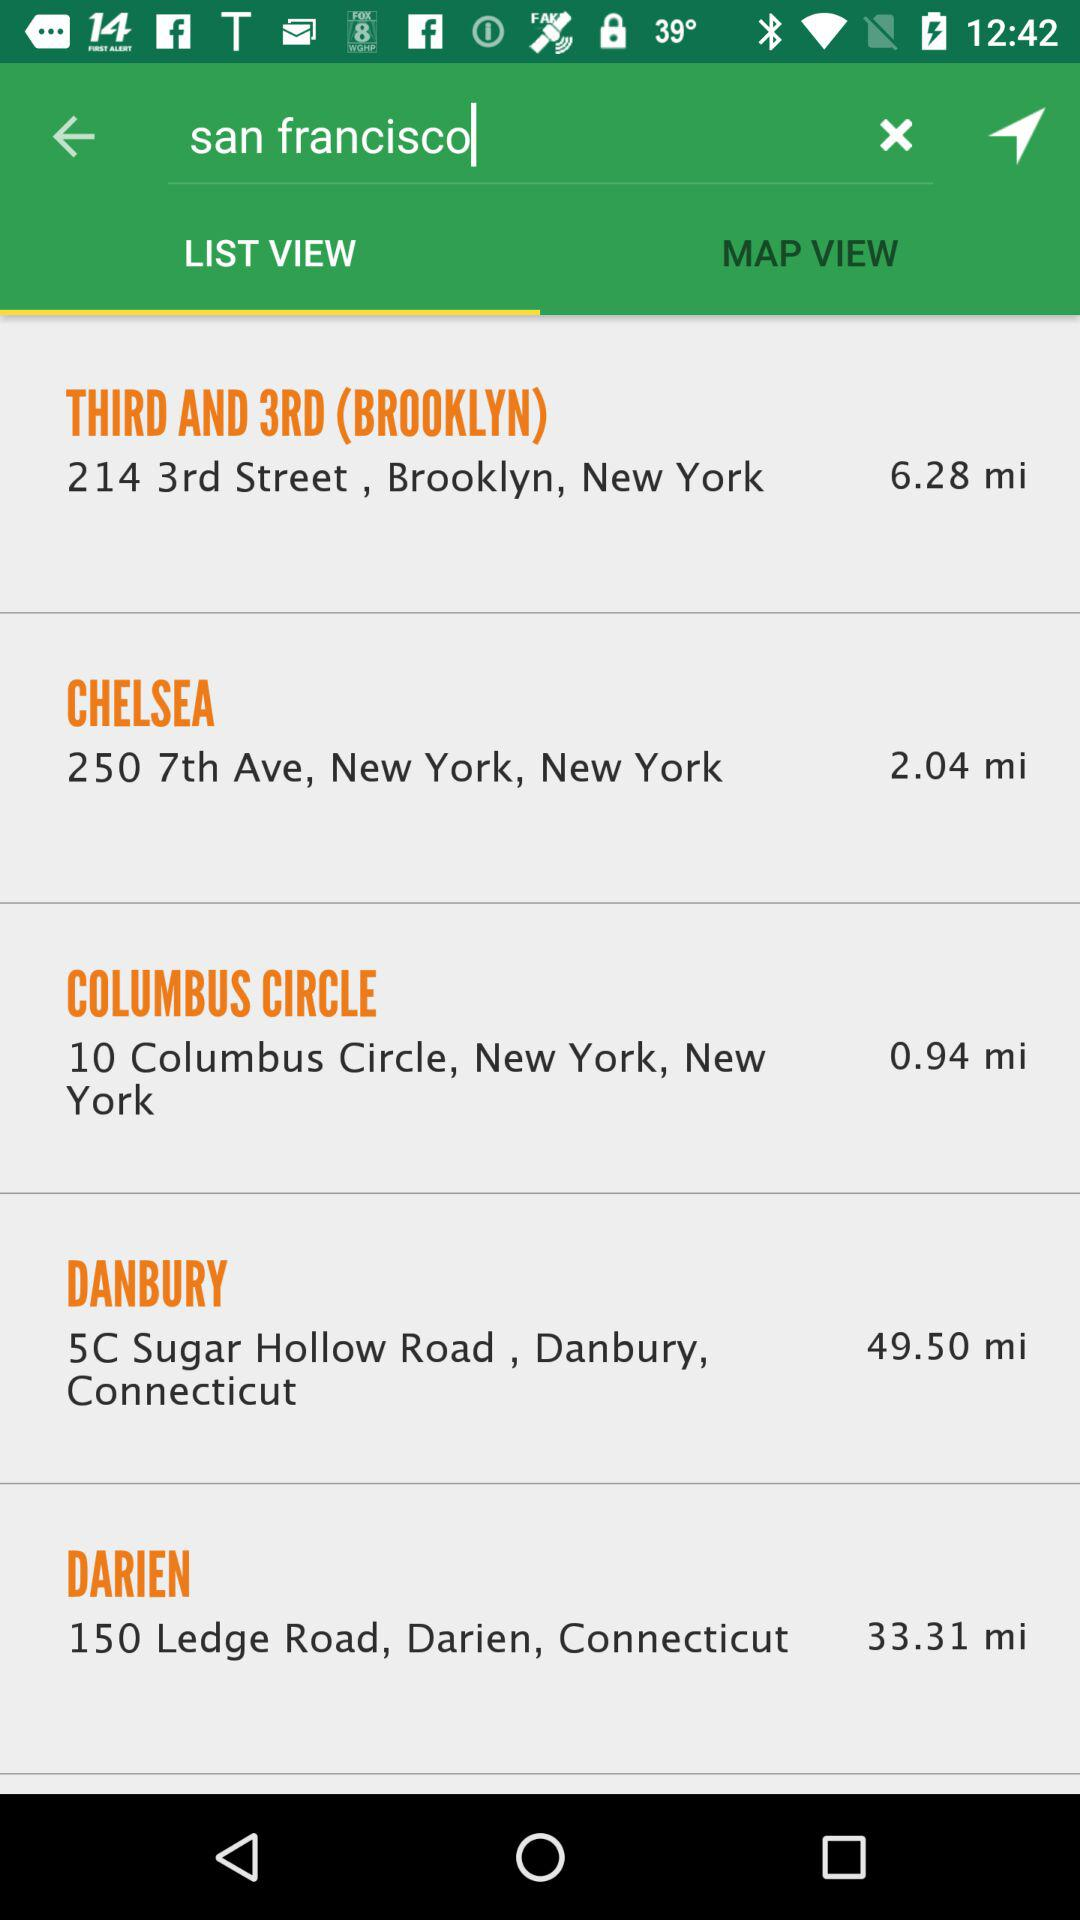What is the entered location? The entered location is San Francisco. 